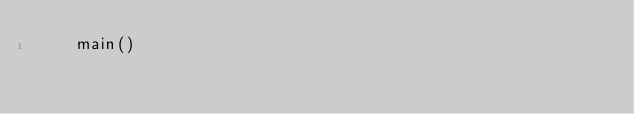<code> <loc_0><loc_0><loc_500><loc_500><_Python_>    main()
</code> 